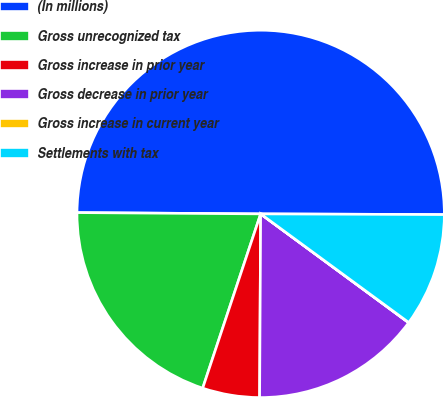Convert chart to OTSL. <chart><loc_0><loc_0><loc_500><loc_500><pie_chart><fcel>(In millions)<fcel>Gross unrecognized tax<fcel>Gross increase in prior year<fcel>Gross decrease in prior year<fcel>Gross increase in current year<fcel>Settlements with tax<nl><fcel>49.95%<fcel>20.0%<fcel>5.02%<fcel>15.0%<fcel>0.02%<fcel>10.01%<nl></chart> 